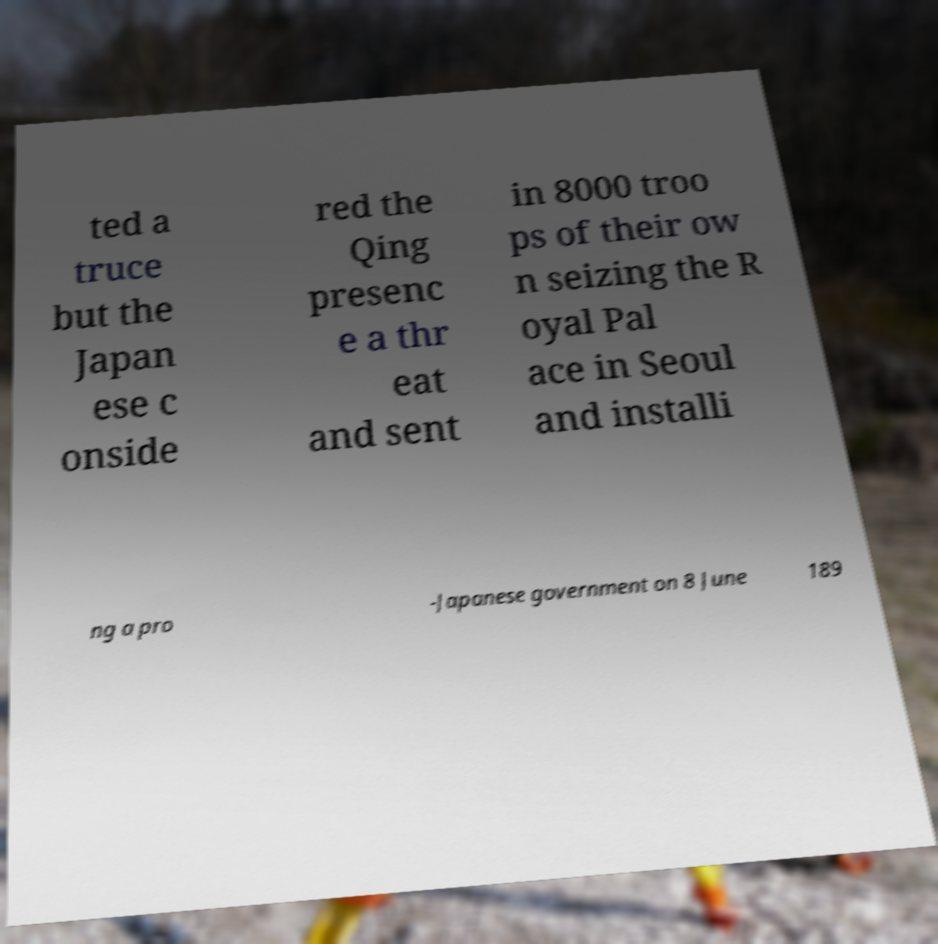Please identify and transcribe the text found in this image. ted a truce but the Japan ese c onside red the Qing presenc e a thr eat and sent in 8000 troo ps of their ow n seizing the R oyal Pal ace in Seoul and installi ng a pro -Japanese government on 8 June 189 